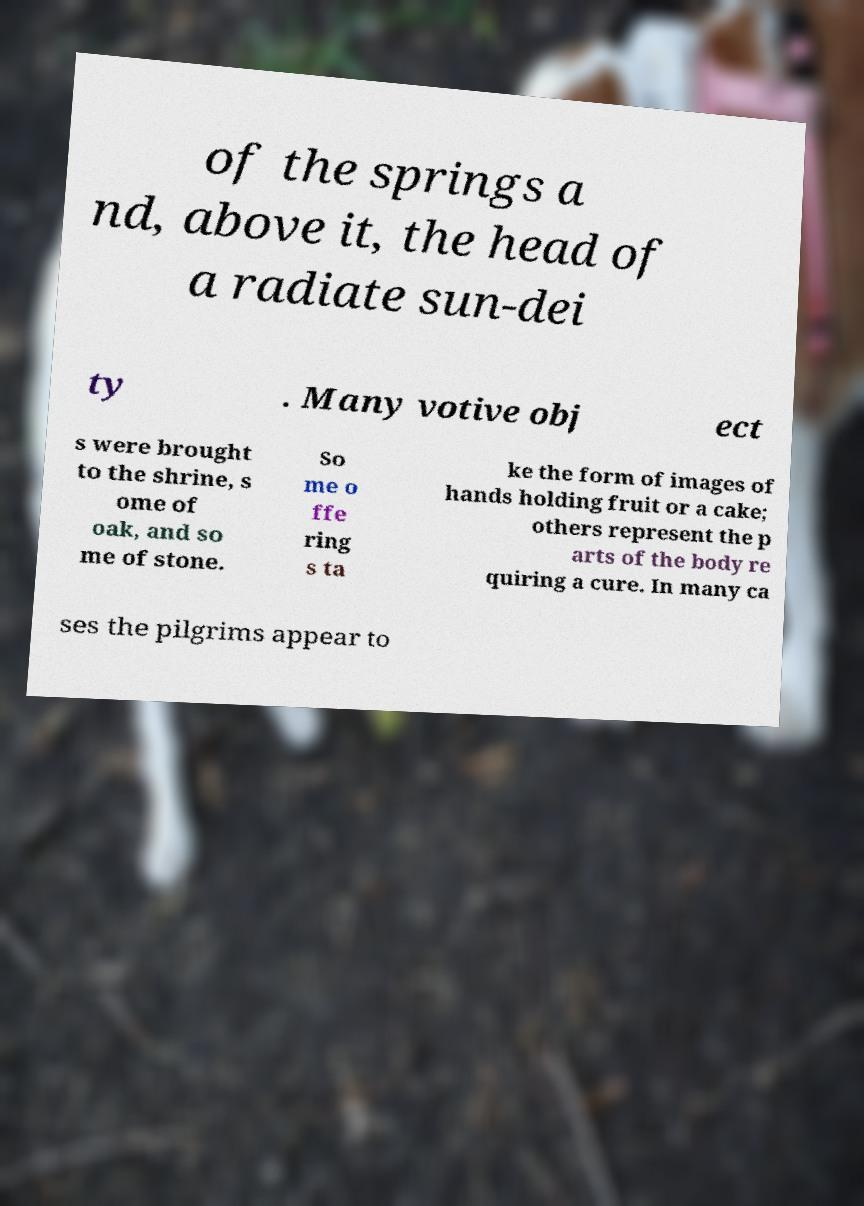Could you assist in decoding the text presented in this image and type it out clearly? of the springs a nd, above it, the head of a radiate sun-dei ty . Many votive obj ect s were brought to the shrine, s ome of oak, and so me of stone. So me o ffe ring s ta ke the form of images of hands holding fruit or a cake; others represent the p arts of the body re quiring a cure. In many ca ses the pilgrims appear to 